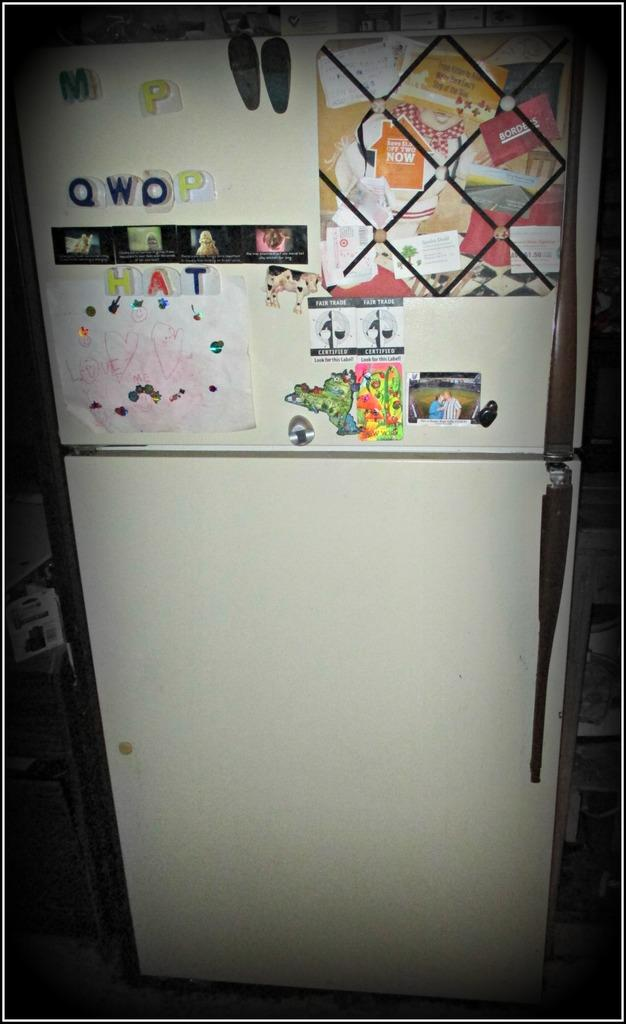What type of appliance is visible in the image? There is a refrigerator in the image. What is attached to the refrigerator? Papers and posters are attached to the refrigerator. Can you see a river flowing behind the refrigerator in the image? There is no river visible in the image; it only features a refrigerator with papers and posters attached to it. 